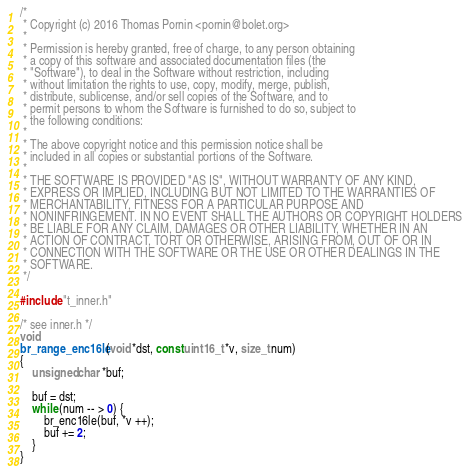<code> <loc_0><loc_0><loc_500><loc_500><_C_>/*
 * Copyright (c) 2016 Thomas Pornin <pornin@bolet.org>
 *
 * Permission is hereby granted, free of charge, to any person obtaining 
 * a copy of this software and associated documentation files (the
 * "Software"), to deal in the Software without restriction, including
 * without limitation the rights to use, copy, modify, merge, publish,
 * distribute, sublicense, and/or sell copies of the Software, and to
 * permit persons to whom the Software is furnished to do so, subject to
 * the following conditions:
 *
 * The above copyright notice and this permission notice shall be 
 * included in all copies or substantial portions of the Software.
 *
 * THE SOFTWARE IS PROVIDED "AS IS", WITHOUT WARRANTY OF ANY KIND, 
 * EXPRESS OR IMPLIED, INCLUDING BUT NOT LIMITED TO THE WARRANTIES OF
 * MERCHANTABILITY, FITNESS FOR A PARTICULAR PURPOSE AND 
 * NONINFRINGEMENT. IN NO EVENT SHALL THE AUTHORS OR COPYRIGHT HOLDERS
 * BE LIABLE FOR ANY CLAIM, DAMAGES OR OTHER LIABILITY, WHETHER IN AN
 * ACTION OF CONTRACT, TORT OR OTHERWISE, ARISING FROM, OUT OF OR IN
 * CONNECTION WITH THE SOFTWARE OR THE USE OR OTHER DEALINGS IN THE
 * SOFTWARE.
 */

#include "t_inner.h"

/* see inner.h */
void
br_range_enc16le(void *dst, const uint16_t *v, size_t num)
{
	unsigned char *buf;

	buf = dst;
	while (num -- > 0) {
		br_enc16le(buf, *v ++);
		buf += 2;
	}
}
</code> 